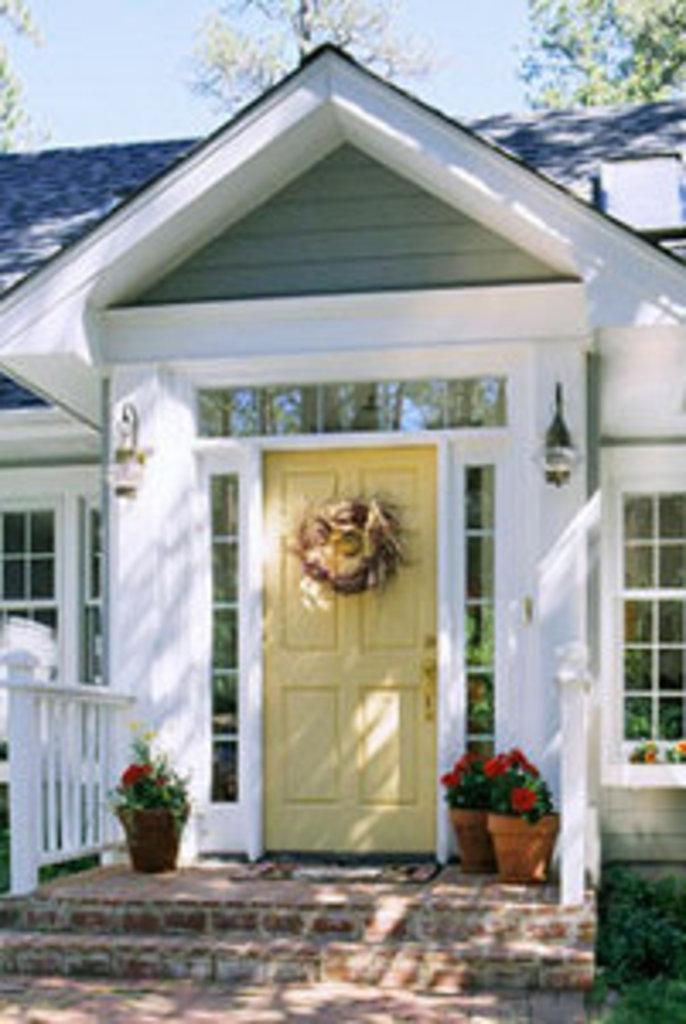Describe this image in one or two sentences. In this picture we can see planets on the path on the right side. There are a few flowers in a flower pot. We can see a door, lanterns and a few windows on the house. There are some trees visible in the background. 